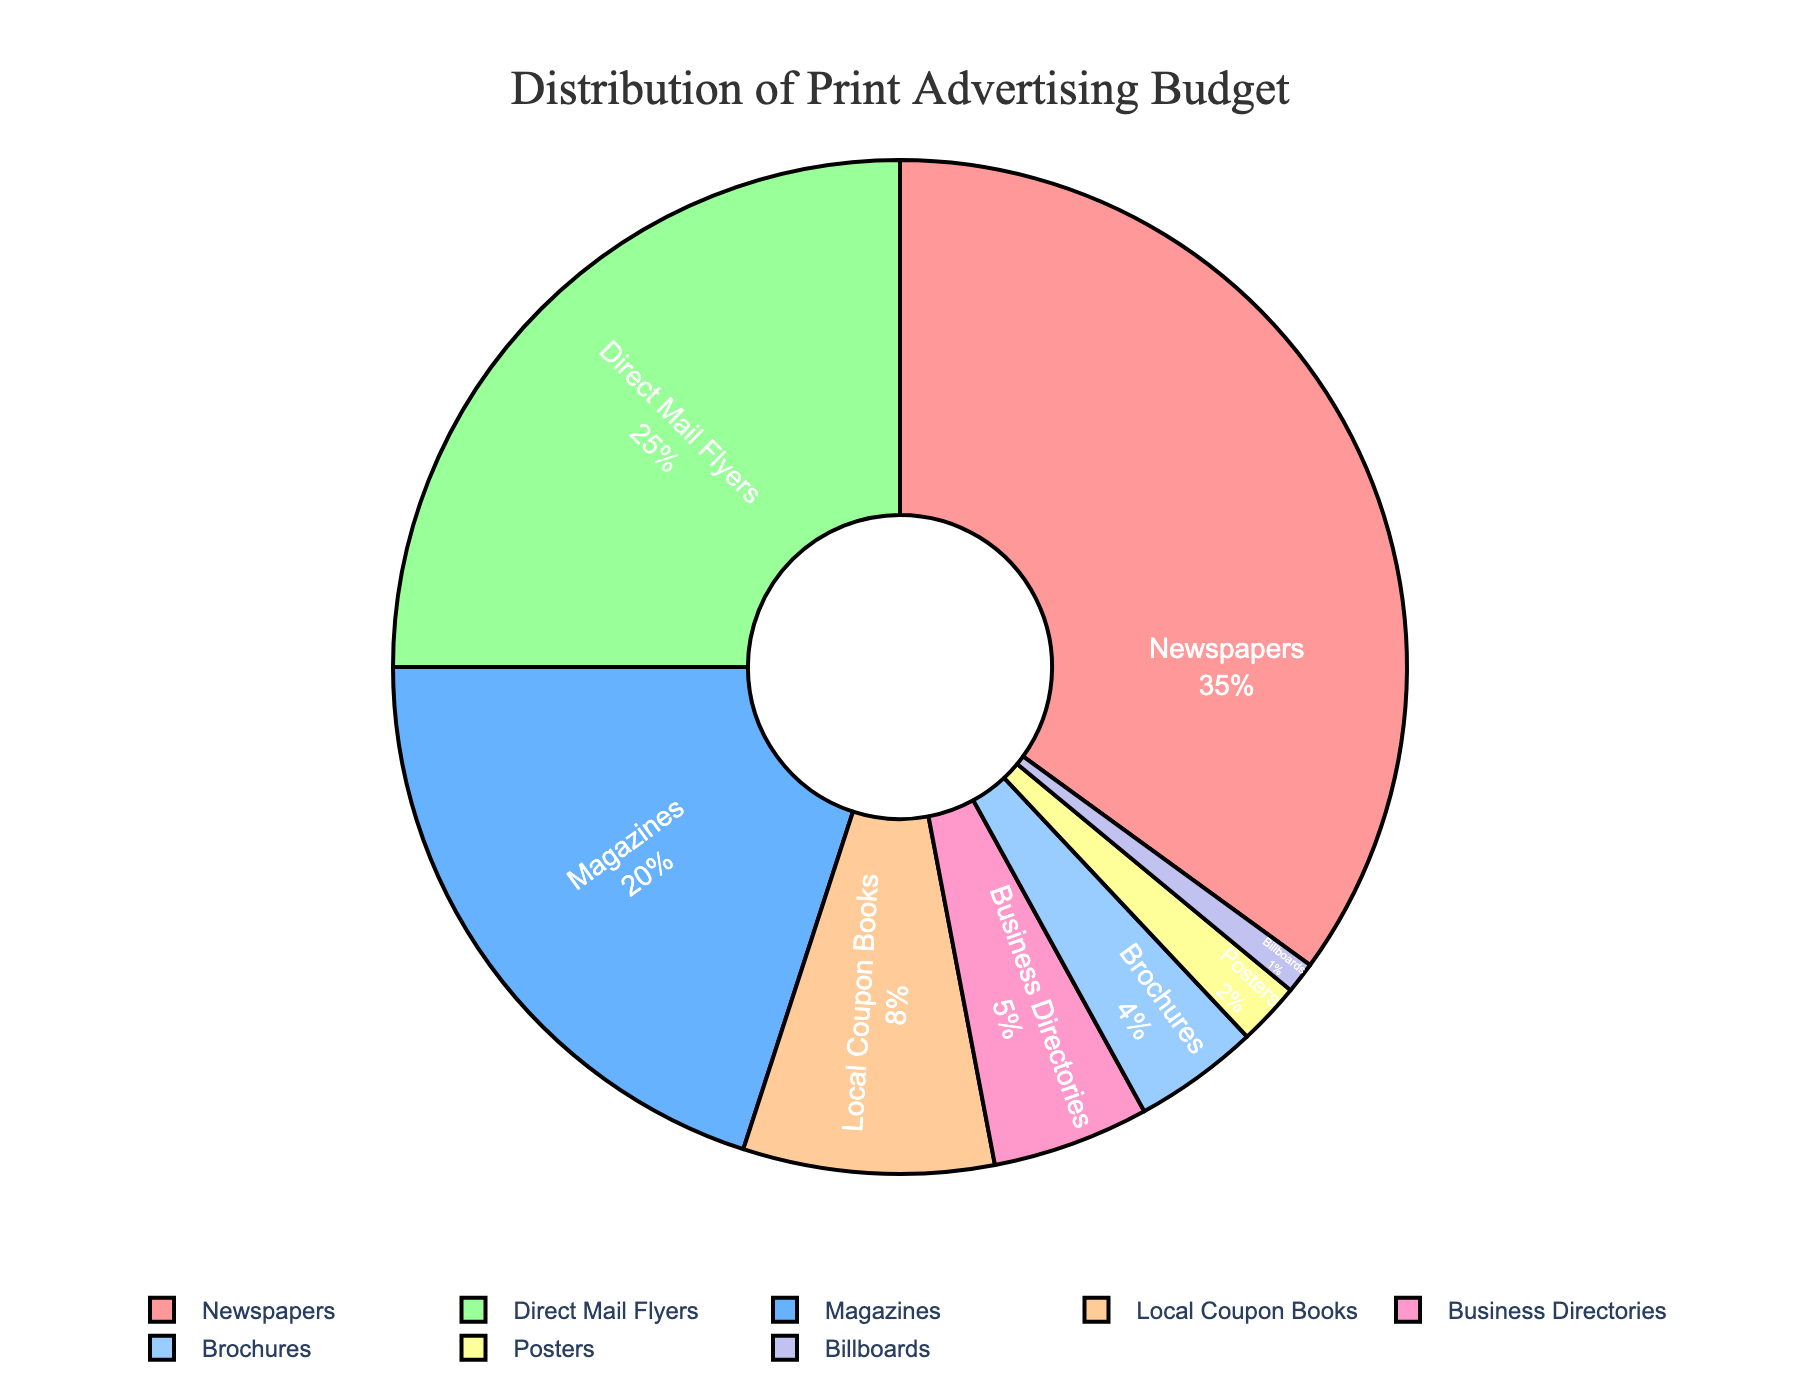What's the percentage of the budget allocated to Newspapers and Magazines combined? To find the combined percentage, add the percentage of the budget allocated to both Newspapers and Magazines. Newspapers have 35% and Magazines have 20%. So, 35% + 20% = 55%.
Answer: 55% Which medium receives more budget: Direct Mail Flyers or Local Coupon Books? Compare the percentages of Direct Mail Flyers (25%) and Local Coupon Books (8%). Since 25% is greater than 8%, Direct Mail Flyers receive more budget.
Answer: Direct Mail Flyers What is the difference in the budget allocation between Business Directories and Brochures? Subtract the percentage allocated to Brochures from the percentage allocated to Business Directories. Business Directories have 5% and Brochures have 4%, so 5% - 4% = 1%.
Answer: 1% Which medium has the smallest budget allocation and what is its percentage? Identify the medium with the smallest percentage value in the pie chart. From the data, Billboards have the smallest allocation at 1%.
Answer: Billboards, 1% What is the total percentage allocated to Direct Mail Flyers, Local Coupon Books, and Business Directories? Add the percentages of Direct Mail Flyers (25%), Local Coupon Books (8%), and Business Directories (5%). So, 25% + 8% + 5% = 38%.
Answer: 38% Which mediums have a budget allocation of less than 10%? Identify the mediums with percentages less than 10% from the pie chart. Local Coupon Books (8%), Business Directories (5%), Brochures (4%), Posters (2%), and Billboards (1%) fit this criteria.
Answer: Local Coupon Books, Business Directories, Brochures, Posters, Billboards Among all the categories listed, which category has the second-largest budget allocation? First, identify the largest allocation which is Newspapers at 35%. The second largest allocation is Direct Mail Flyers at 25%.
Answer: Direct Mail Flyers What's the average budget allocation across all eight mediums? Sum all percentages and divide by the number of mediums. (35% + 20% + 25% + 8% + 5% + 4% + 2% + 1%) / 8 = 100% / 8 = 12.5%.
Answer: 12.5% Which two mediums combined have a budget allocation closest to 30%? Evaluate pairs of mediums to see which combination is closest to 30%. Brochures (4%) and Posters (2%) combined give 6%, not close. Magazines (20%) and Local Coupon Books (8%) result in 28%, which is closer to 30% compared to other combinations.
Answer: Magazines and Local Coupon Books 